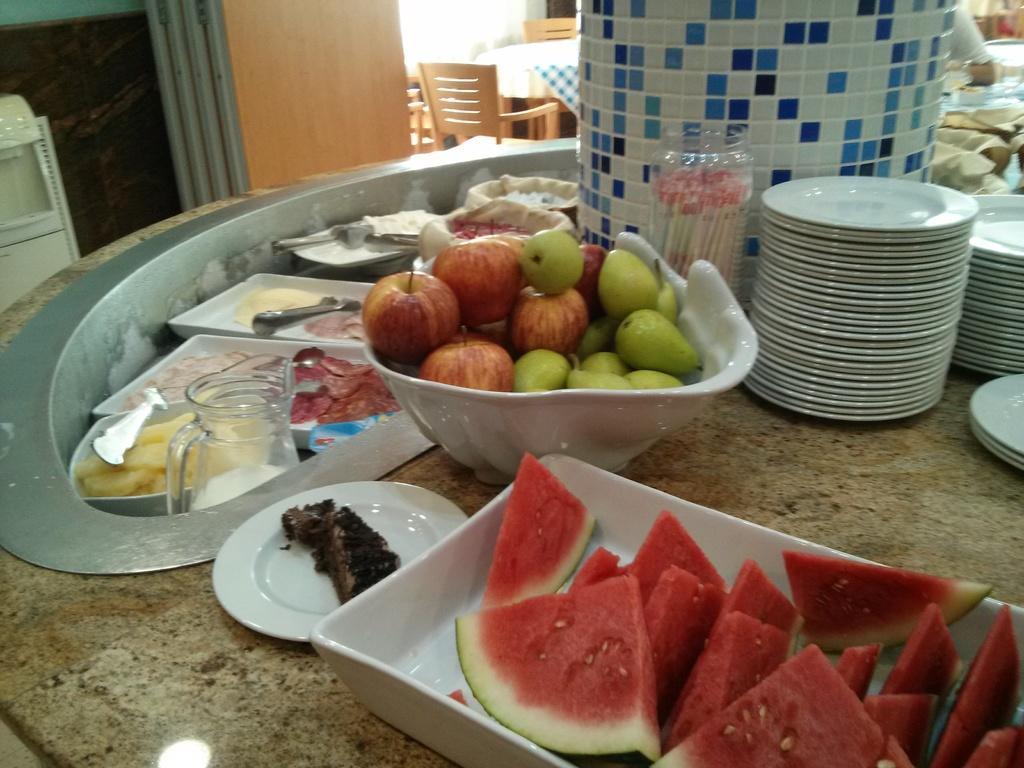How would you summarize this image in a sentence or two? In this picture we can see a platform, there are some plates, a bowl and a tray present on it, we can see some pieces of watermelon in this tree, there are some fruits present in this bowl, we can see a jar here, in the background there is a table and two chairs, we can see a wall here. 